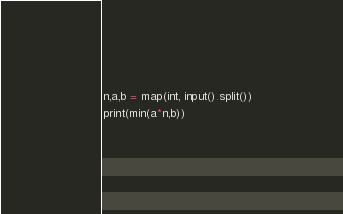Convert code to text. <code><loc_0><loc_0><loc_500><loc_500><_Python_>n,a,b = map(int, input().split())
print(min(a*n,b))
</code> 